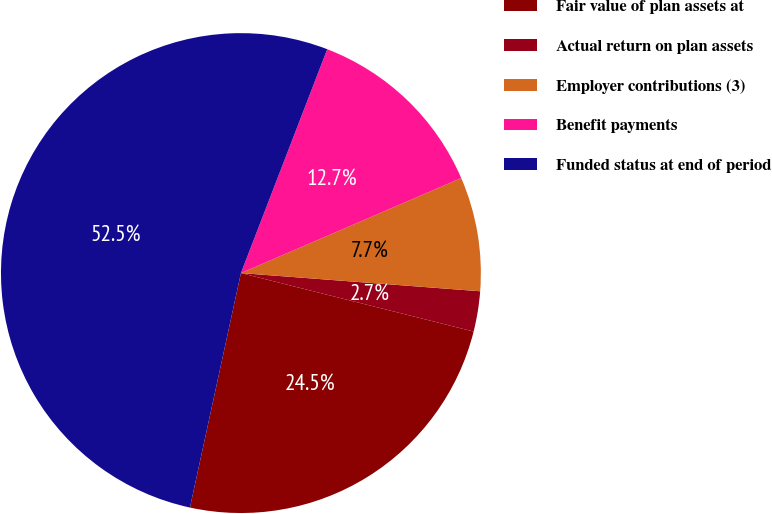<chart> <loc_0><loc_0><loc_500><loc_500><pie_chart><fcel>Fair value of plan assets at<fcel>Actual return on plan assets<fcel>Employer contributions (3)<fcel>Benefit payments<fcel>Funded status at end of period<nl><fcel>24.49%<fcel>2.71%<fcel>7.69%<fcel>12.66%<fcel>52.45%<nl></chart> 